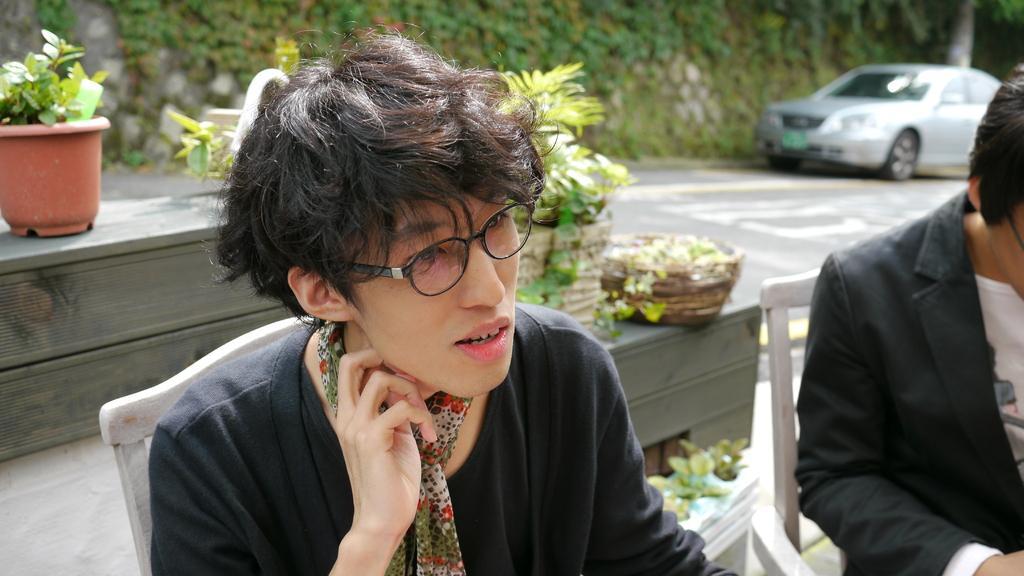Can you describe this image briefly? In this image there are two people sitting on their chairs, behind them there are a few plant pots on the wooden objects. In the background there is a vehicle on the road, trees and a wall. 